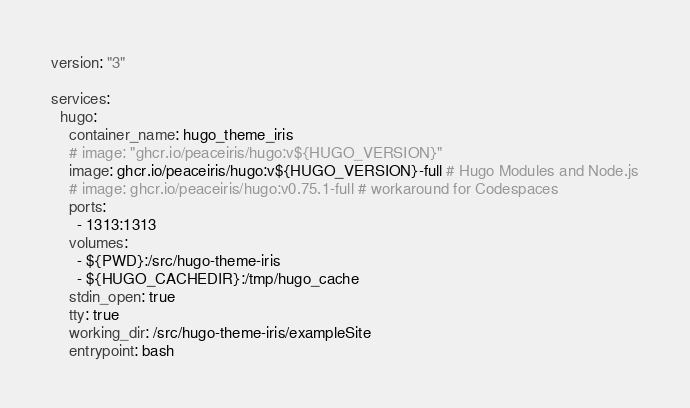<code> <loc_0><loc_0><loc_500><loc_500><_YAML_>version: "3"

services:
  hugo:
    container_name: hugo_theme_iris
    # image: "ghcr.io/peaceiris/hugo:v${HUGO_VERSION}"
    image: ghcr.io/peaceiris/hugo:v${HUGO_VERSION}-full # Hugo Modules and Node.js
    # image: ghcr.io/peaceiris/hugo:v0.75.1-full # workaround for Codespaces
    ports:
      - 1313:1313
    volumes:
      - ${PWD}:/src/hugo-theme-iris
      - ${HUGO_CACHEDIR}:/tmp/hugo_cache
    stdin_open: true
    tty: true
    working_dir: /src/hugo-theme-iris/exampleSite
    entrypoint: bash
</code> 